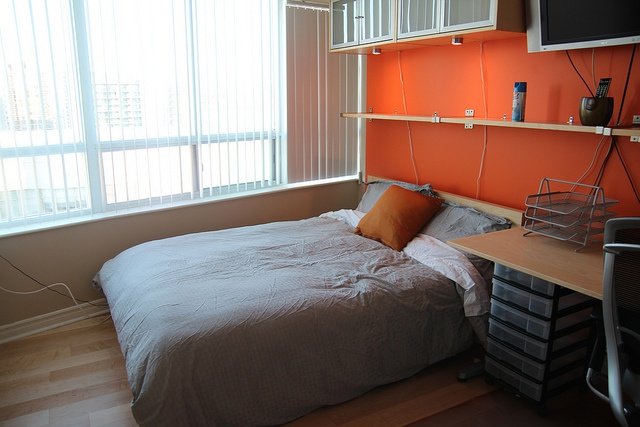Describe the objects in this image and their specific colors. I can see bed in white, black, darkgray, and gray tones, chair in white, black, gray, and darkgray tones, and tv in white, black, darkgray, and gray tones in this image. 